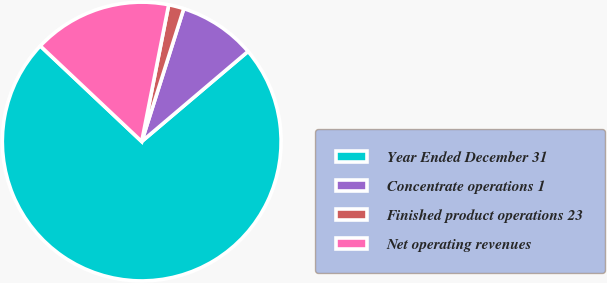<chart> <loc_0><loc_0><loc_500><loc_500><pie_chart><fcel>Year Ended December 31<fcel>Concentrate operations 1<fcel>Finished product operations 23<fcel>Net operating revenues<nl><fcel>73.22%<fcel>8.93%<fcel>1.78%<fcel>16.07%<nl></chart> 